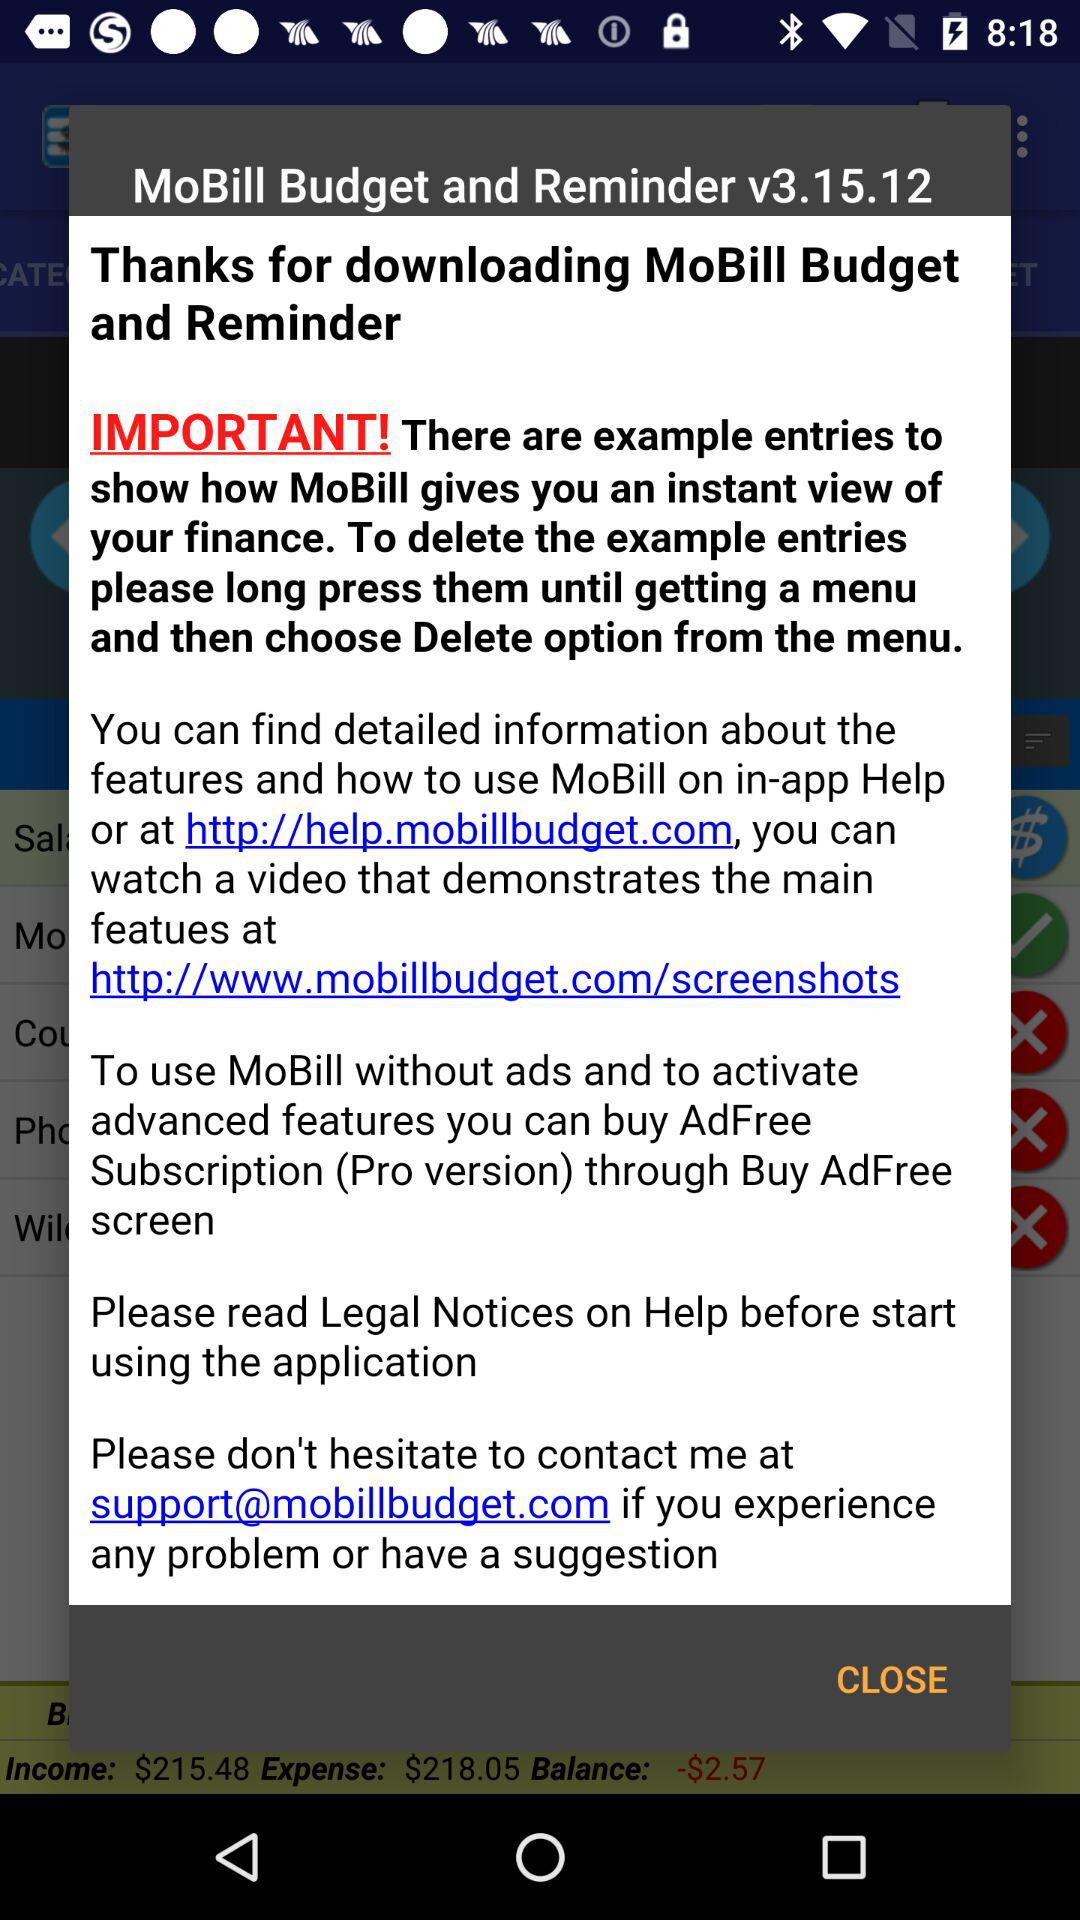What is the application name? The application name is "MoBill Budget and Reminder". 